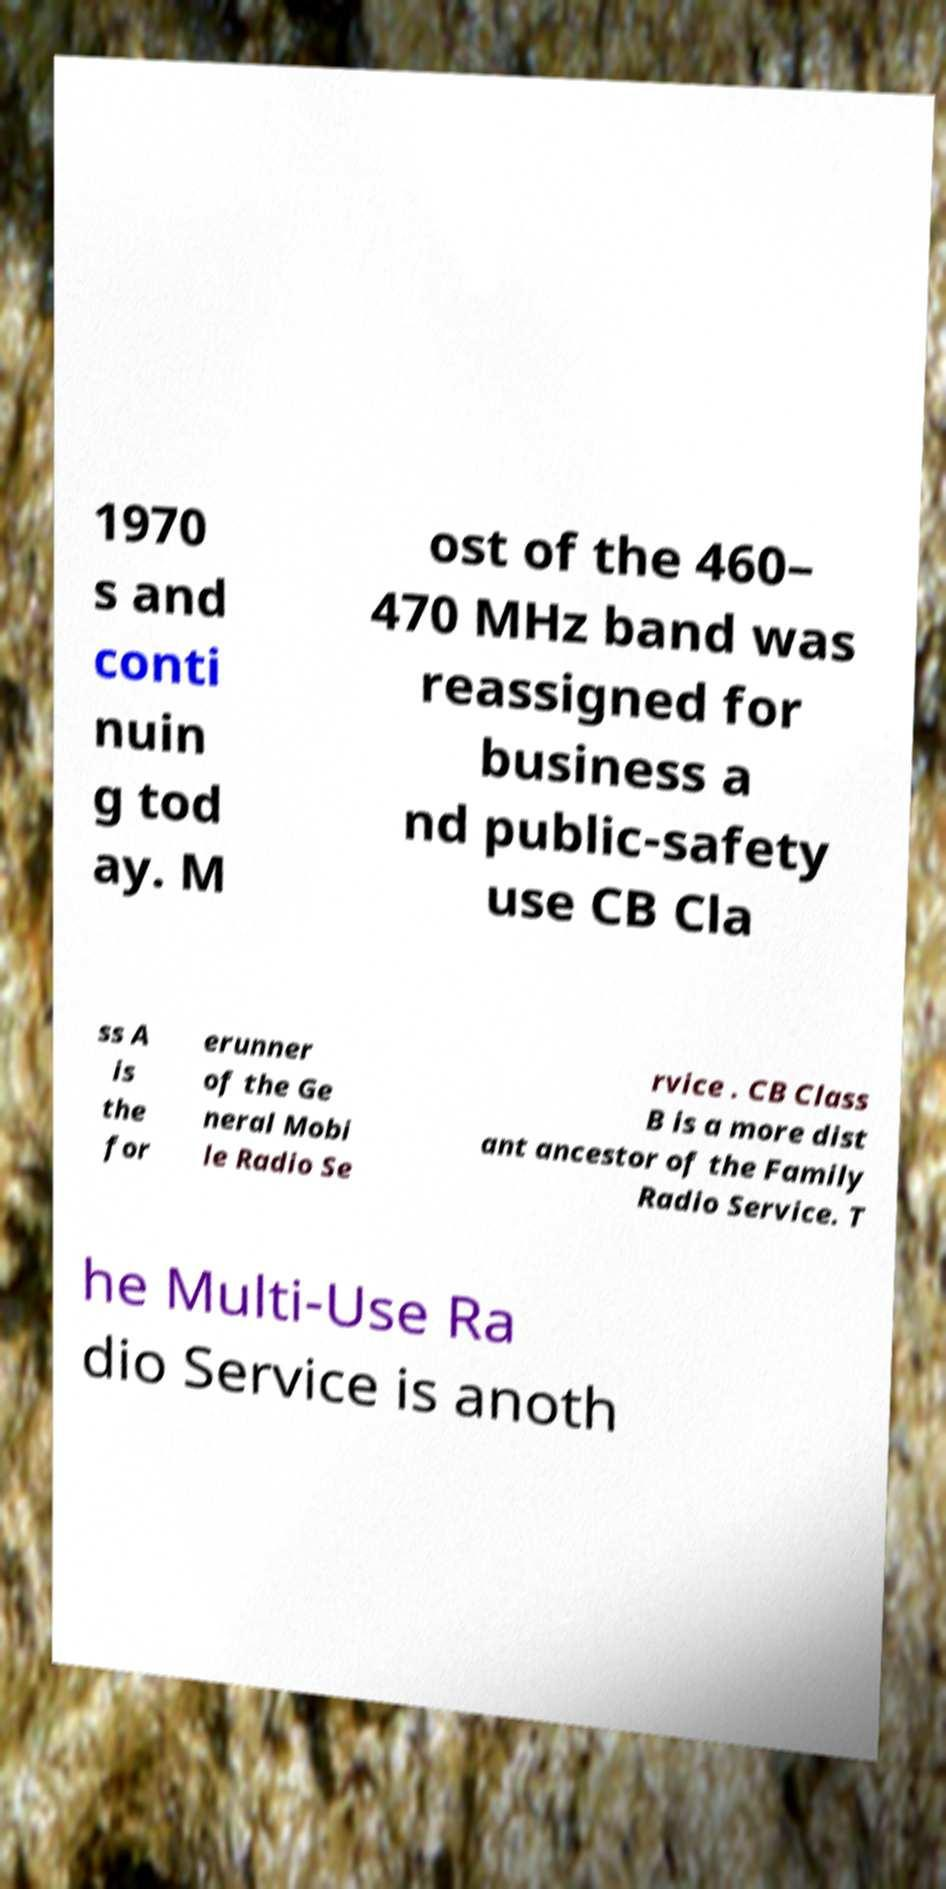Can you accurately transcribe the text from the provided image for me? 1970 s and conti nuin g tod ay. M ost of the 460– 470 MHz band was reassigned for business a nd public-safety use CB Cla ss A is the for erunner of the Ge neral Mobi le Radio Se rvice . CB Class B is a more dist ant ancestor of the Family Radio Service. T he Multi-Use Ra dio Service is anoth 